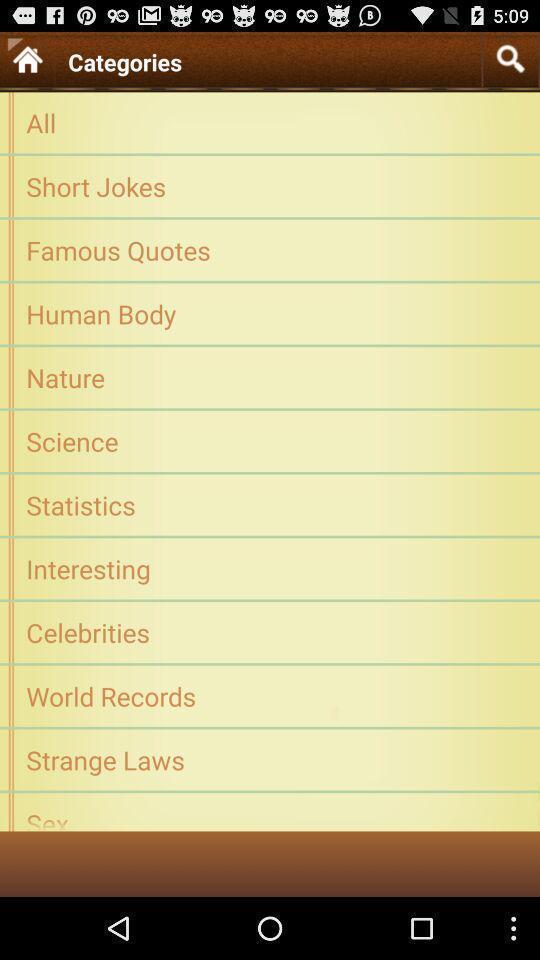What is the overall content of this screenshot? Page showing list of categories. 